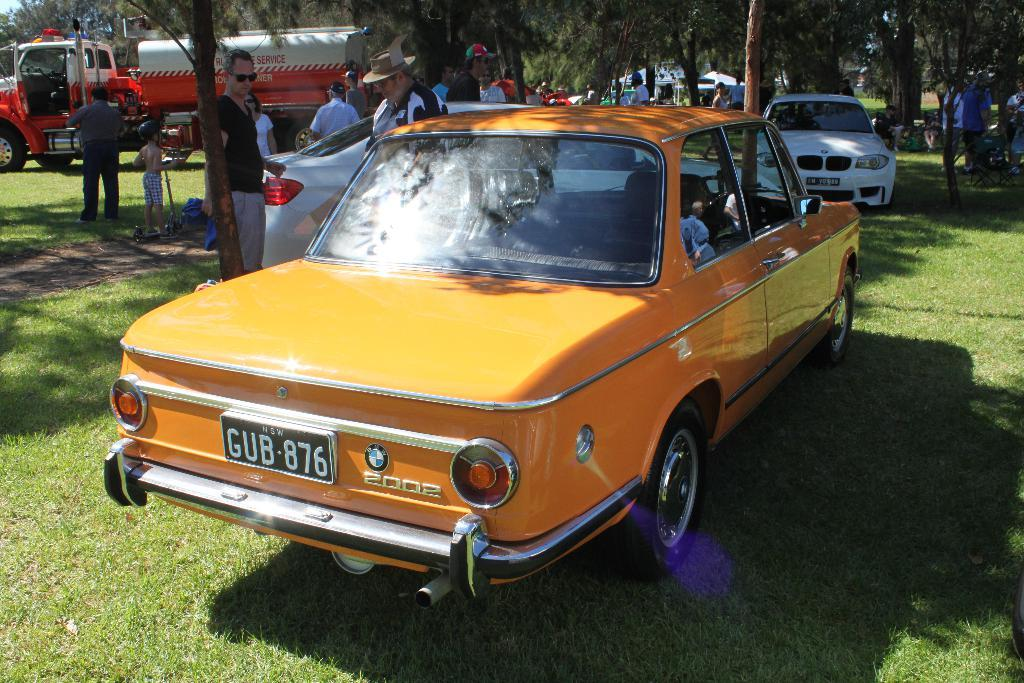Who or what can be seen in the image? There are people in the image. What else is present in the image besides people? There are vehicles in the image. What type of natural environment is visible in the image? The grass is visible in the image. What can be seen in the background of the image? There are trees and tents in the background of the image. Where is the faucet located in the image? There is no faucet present in the image. What type of poison is being used by the people in the image? There is no mention or indication of poison in the image. 